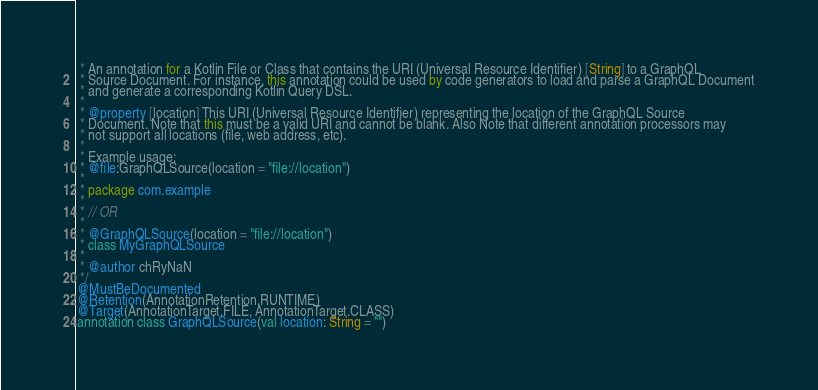<code> <loc_0><loc_0><loc_500><loc_500><_Kotlin_> * An annotation for a Kotlin File or Class that contains the URI (Universal Resource Identifier) [String] to a GraphQL
 * Source Document. For instance, this annotation could be used by code generators to load and parse a GraphQL Document
 * and generate a corresponding Kotlin Query DSL.
 *
 * @property [location] This URI (Universal Resource Identifier) representing the location of the GraphQL Source
 * Document. Note that this must be a valid URI and cannot be blank. Also Note that different annotation processors may
 * not support all locations (file, web address, etc).
 *
 * Example usage:
 * @file:GraphQLSource(location = "file://location")
 *
 * package com.example
 *
 * // OR
 *
 * @GraphQLSource(location = "file://location")
 * class MyGraphQLSource
 *
 * @author chRyNaN
 */
@MustBeDocumented
@Retention(AnnotationRetention.RUNTIME)
@Target(AnnotationTarget.FILE, AnnotationTarget.CLASS)
annotation class GraphQLSource(val location: String = "")
</code> 